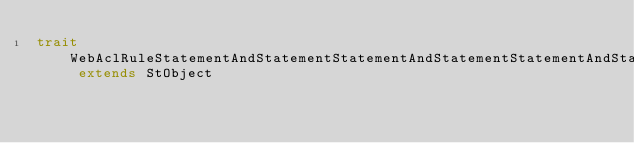Convert code to text. <code><loc_0><loc_0><loc_500><loc_500><_Scala_>trait WebAclRuleStatementAndStatementStatementAndStatementStatementAndStatementStatementSqliMatchStatementFieldToMatchQueryString extends StObject
</code> 